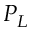<formula> <loc_0><loc_0><loc_500><loc_500>P _ { L }</formula> 